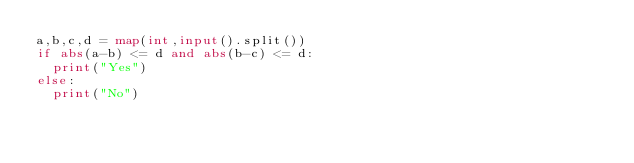Convert code to text. <code><loc_0><loc_0><loc_500><loc_500><_Python_>a,b,c,d = map(int,input().split())
if abs(a-b) <= d and abs(b-c) <= d:
  print("Yes")
else:
  print("No")
</code> 